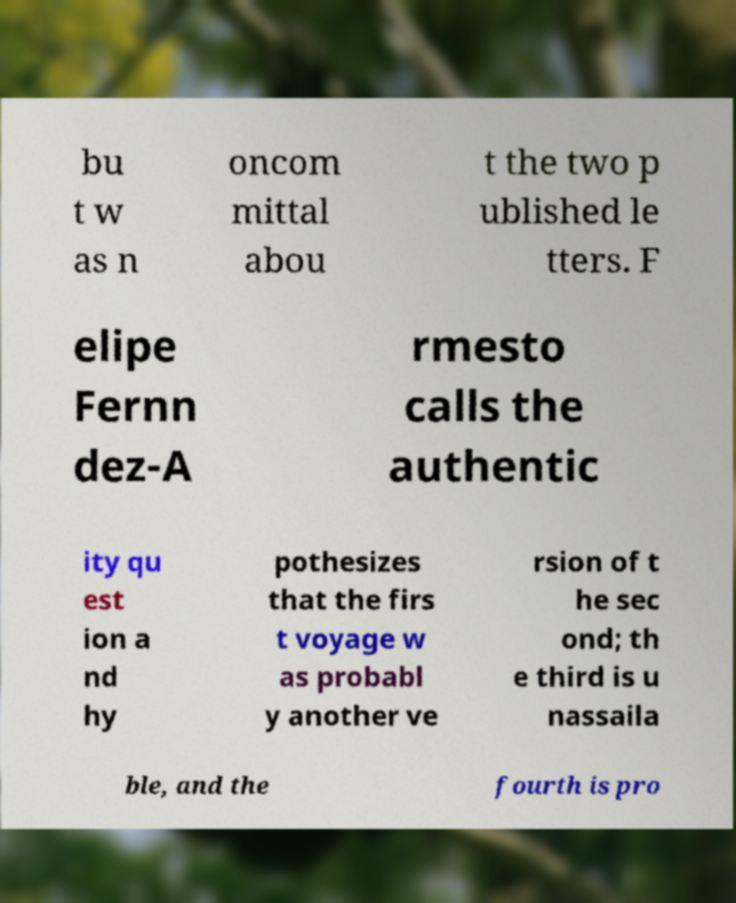Please identify and transcribe the text found in this image. bu t w as n oncom mittal abou t the two p ublished le tters. F elipe Fernn dez-A rmesto calls the authentic ity qu est ion a nd hy pothesizes that the firs t voyage w as probabl y another ve rsion of t he sec ond; th e third is u nassaila ble, and the fourth is pro 